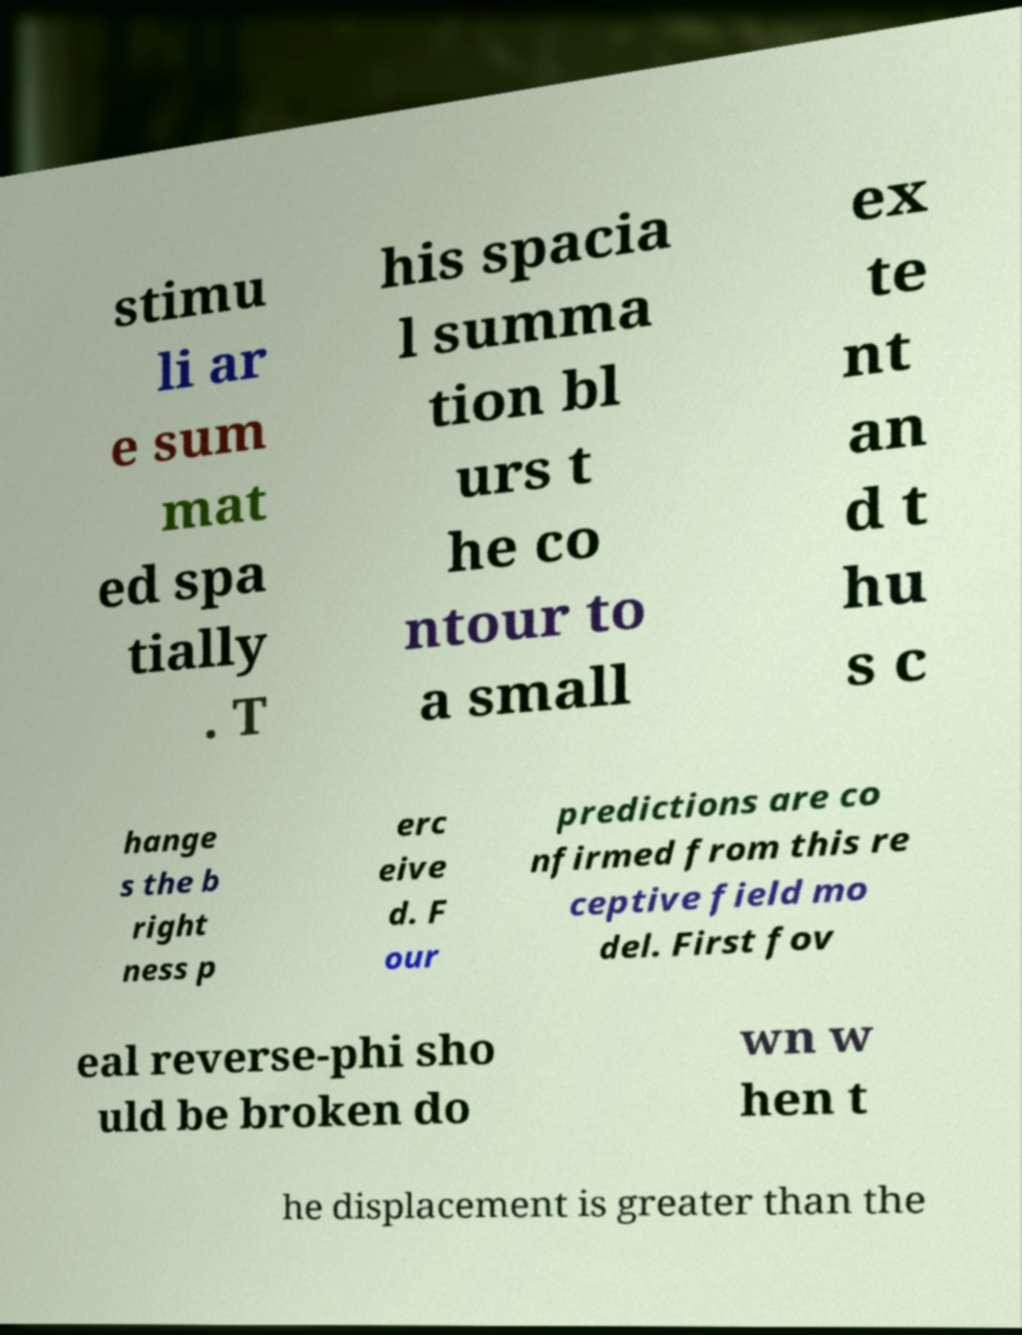For documentation purposes, I need the text within this image transcribed. Could you provide that? stimu li ar e sum mat ed spa tially . T his spacia l summa tion bl urs t he co ntour to a small ex te nt an d t hu s c hange s the b right ness p erc eive d. F our predictions are co nfirmed from this re ceptive field mo del. First fov eal reverse-phi sho uld be broken do wn w hen t he displacement is greater than the 